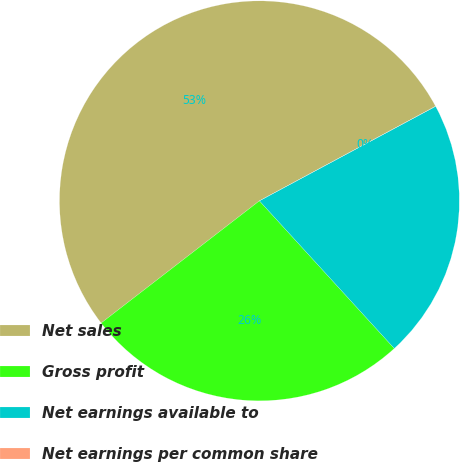<chart> <loc_0><loc_0><loc_500><loc_500><pie_chart><fcel>Net sales<fcel>Gross profit<fcel>Net earnings available to<fcel>Net earnings per common share<nl><fcel>52.62%<fcel>26.32%<fcel>21.05%<fcel>0.01%<nl></chart> 